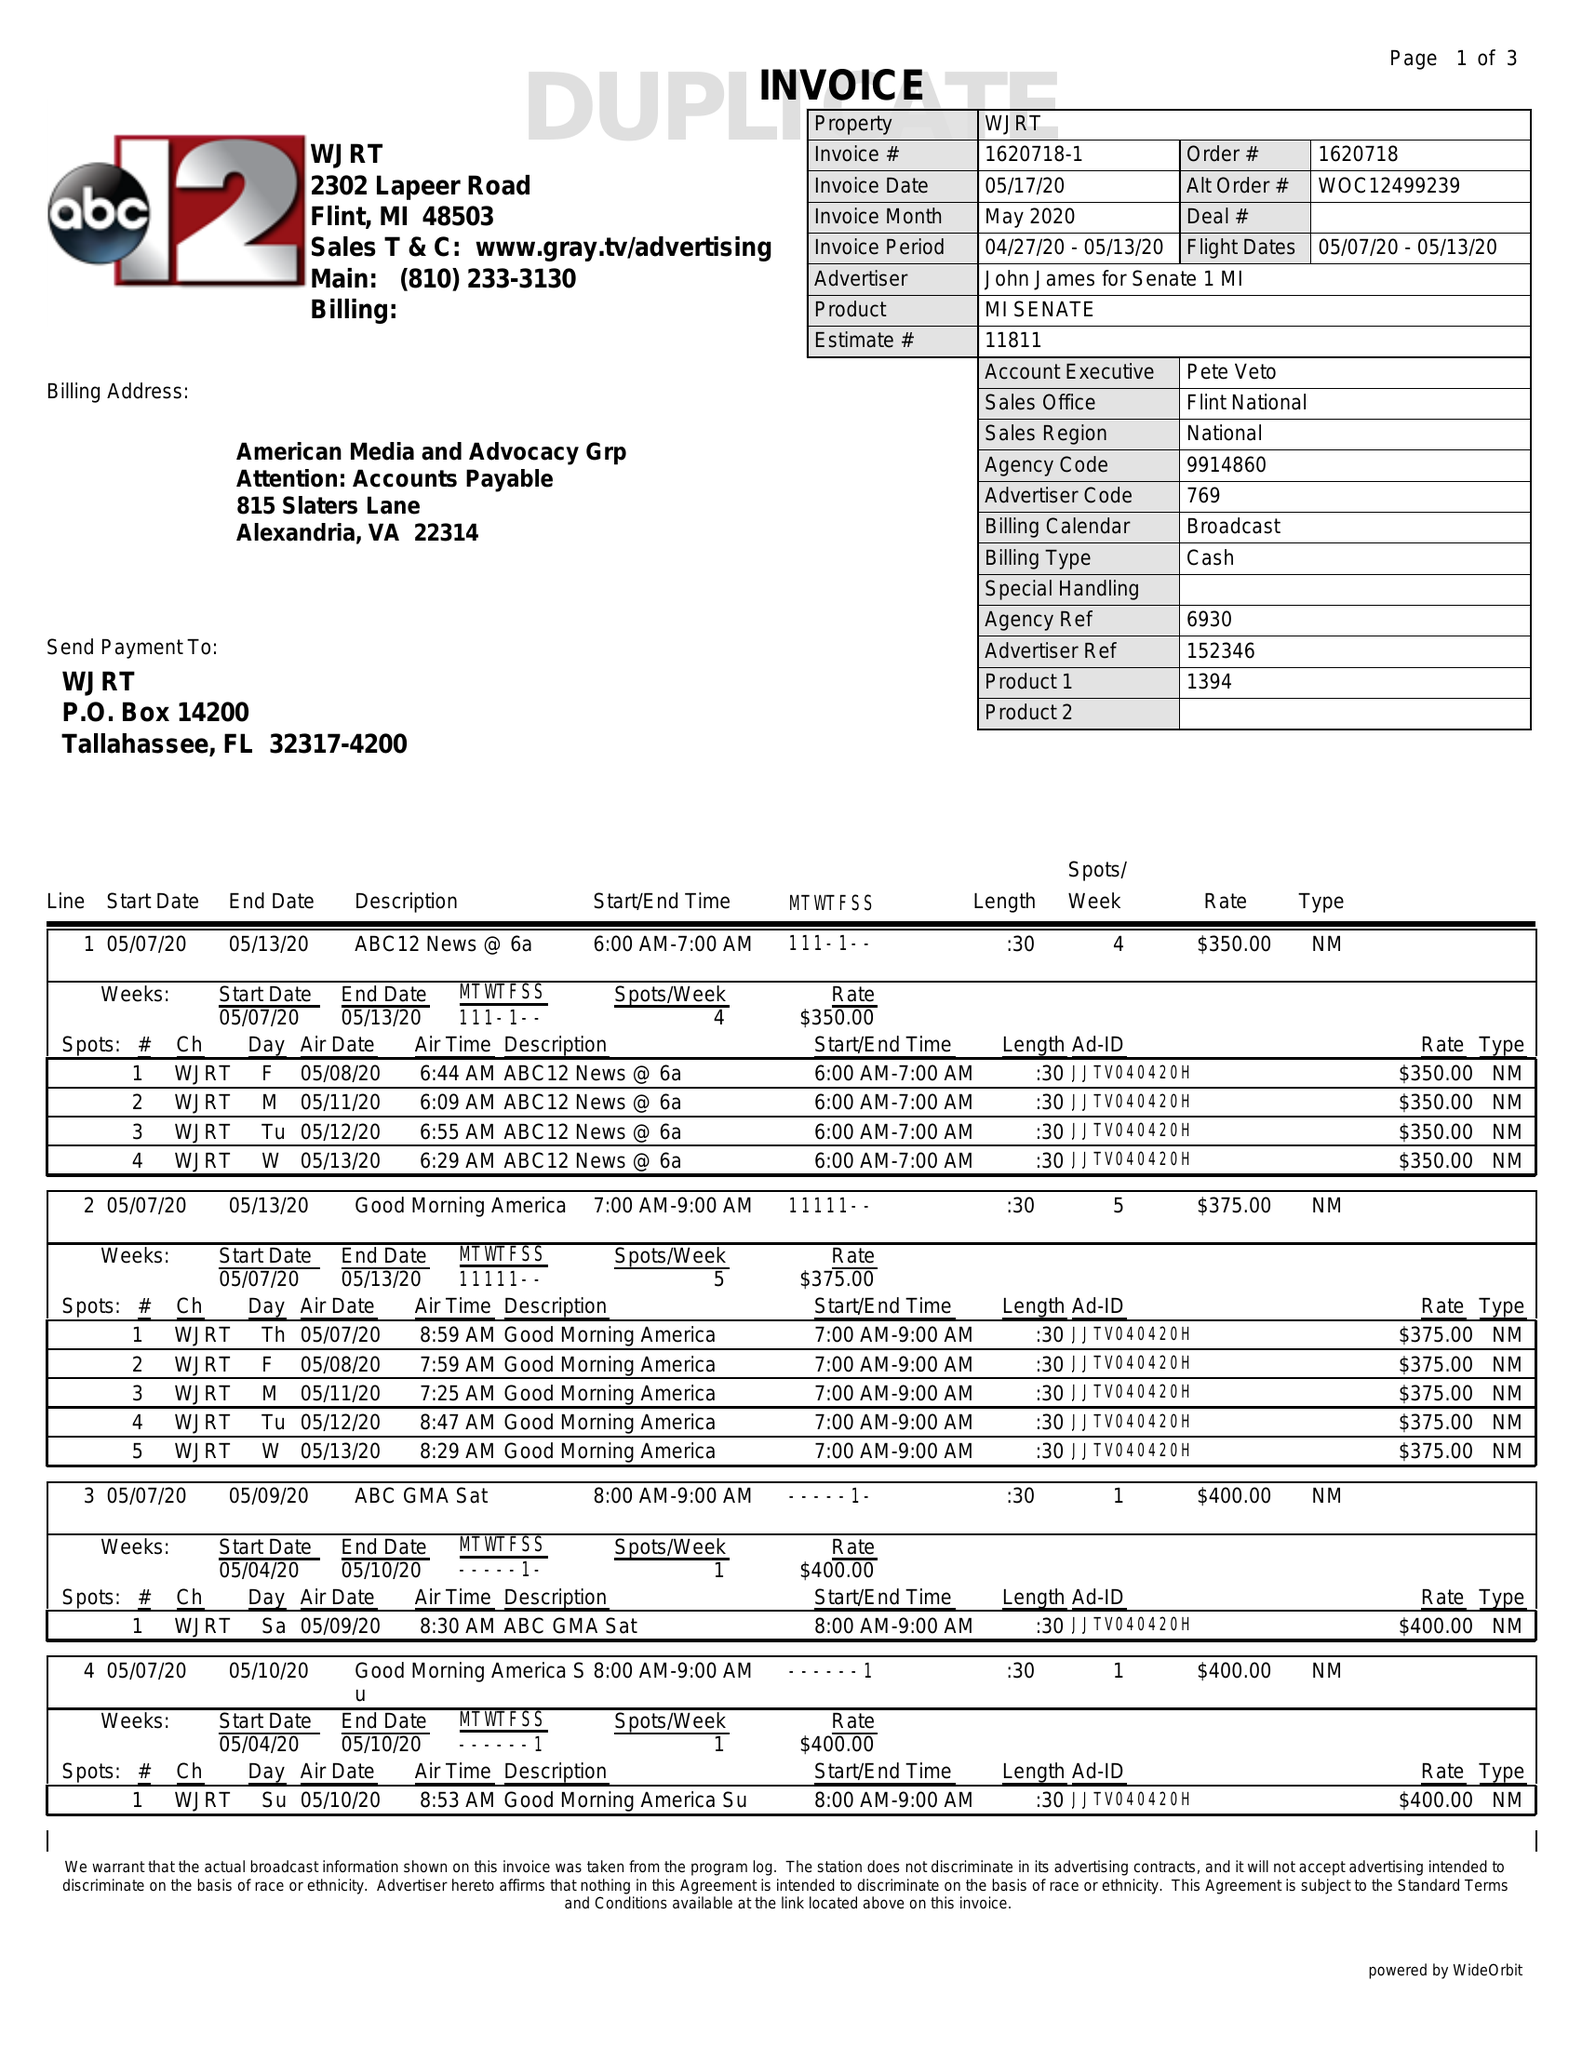What is the value for the gross_amount?
Answer the question using a single word or phrase. 15275.00 